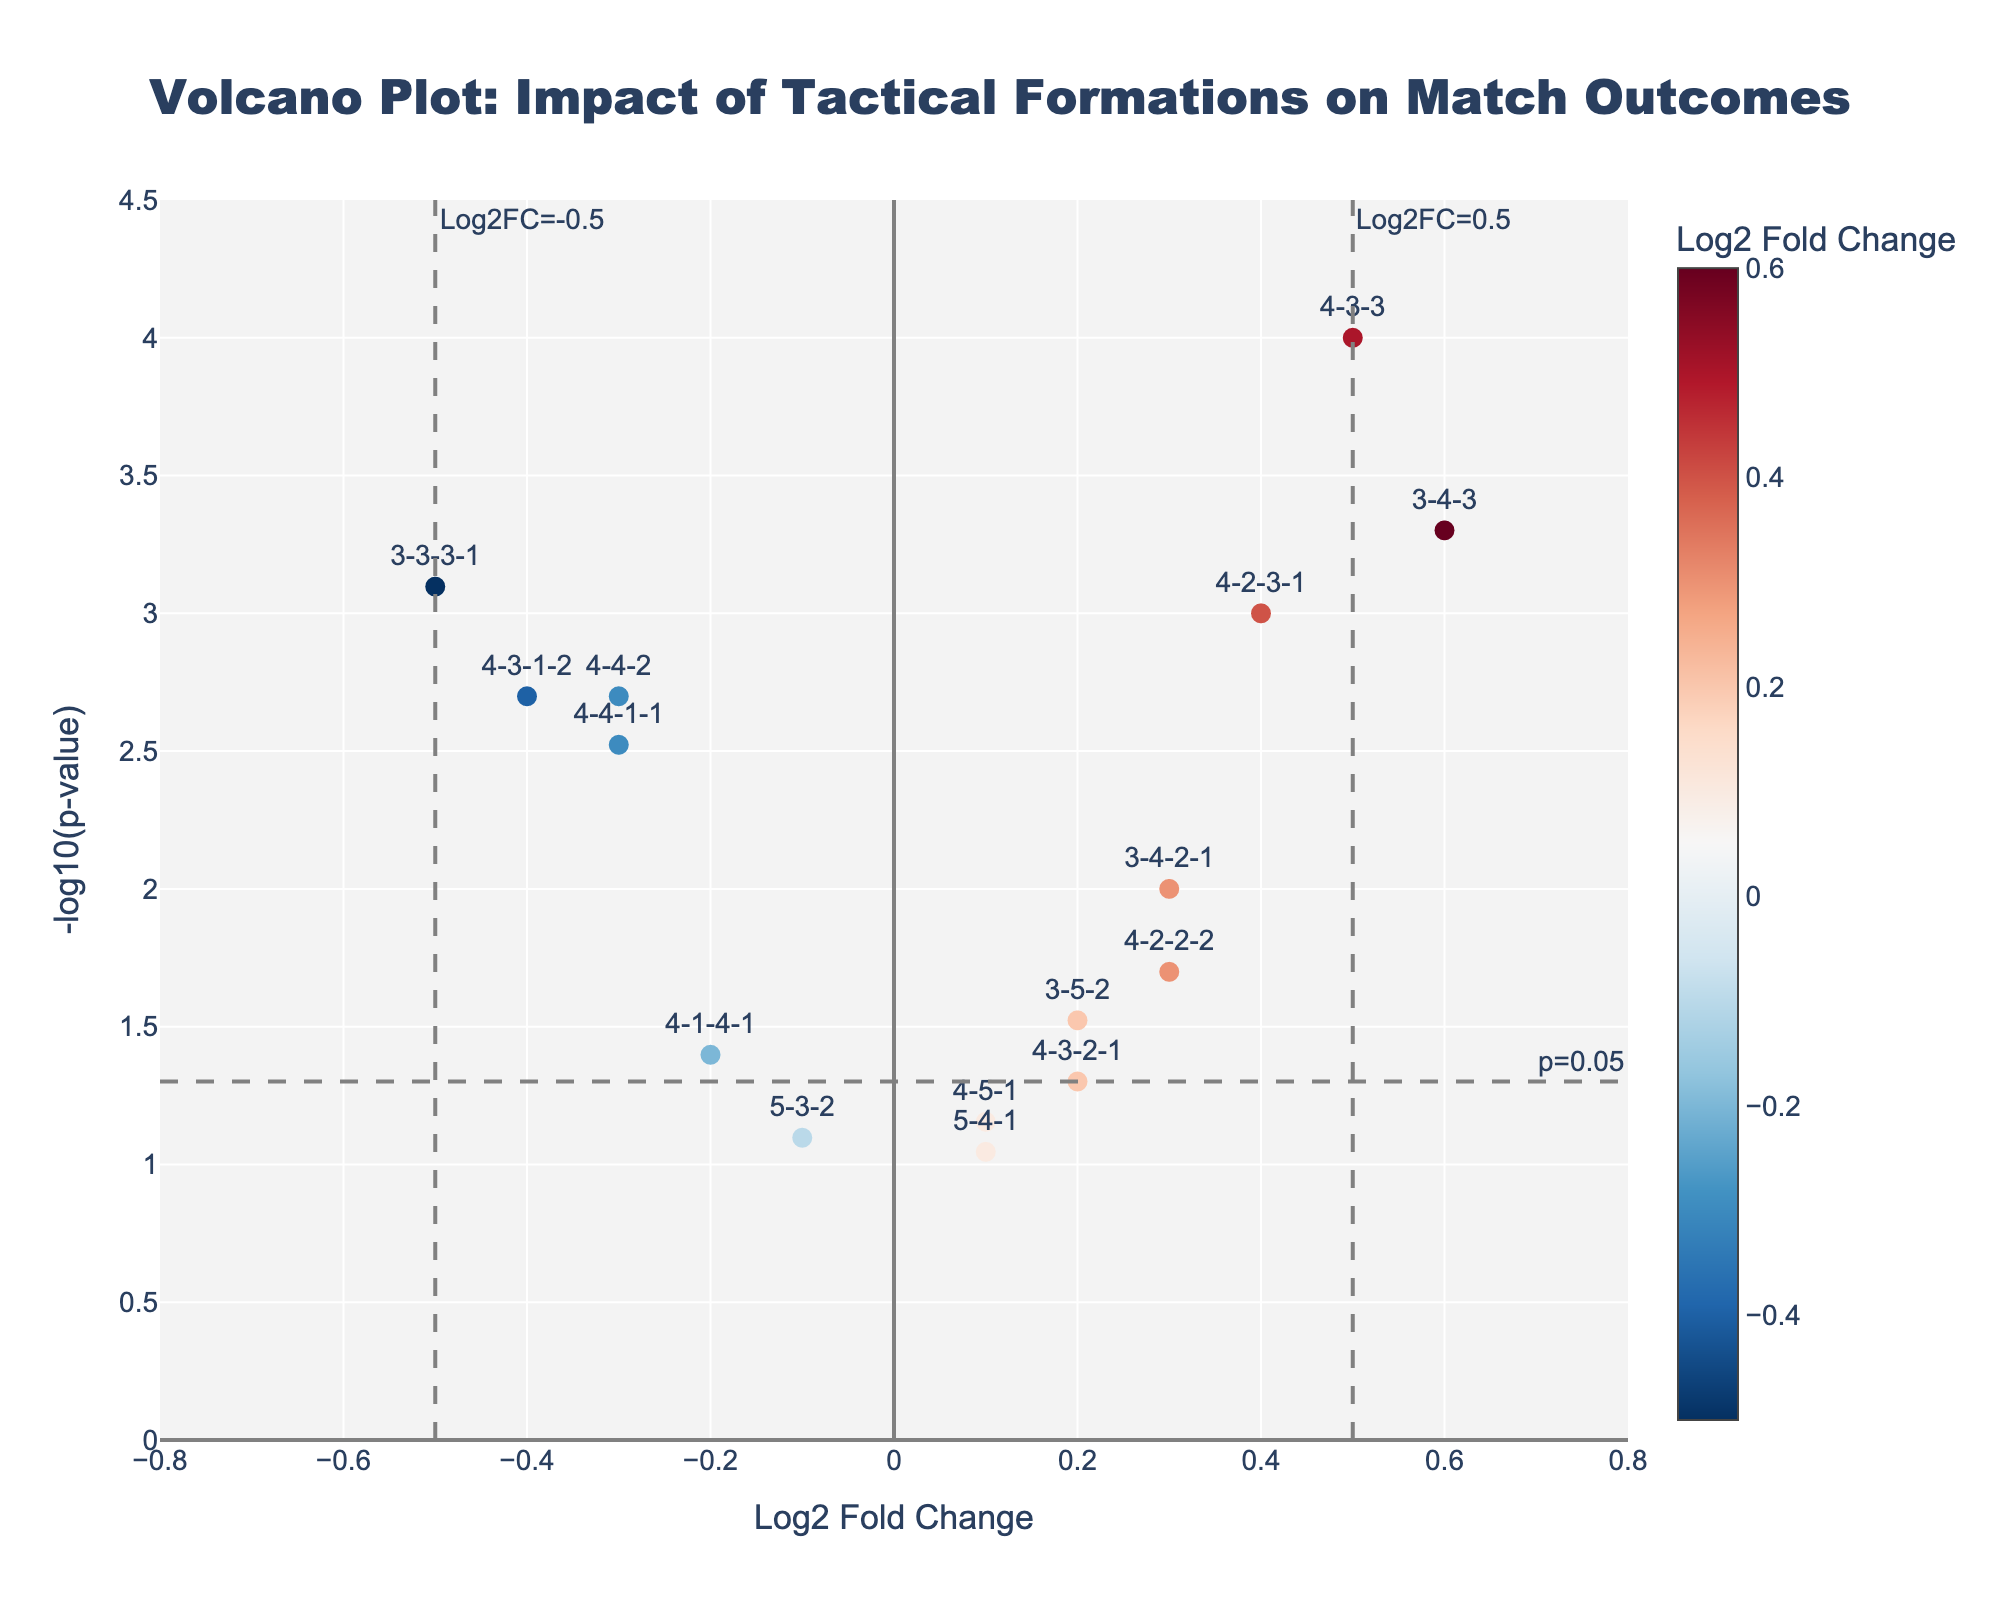What is the title of the plot? The title can be easily located at the top center of the figure. It reads "Volcano Plot: Impact of Tactical Formations on Match Outcomes".
Answer: Volcano Plot: Impact of Tactical Formations on Match Outcomes What are the x-axis and y-axis labels? The x-axis label is "Log2 Fold Change", and the y-axis label is "-log10(p-value)". These labels describe what each axis represents.
Answer: Log2 Fold Change, -log10(p-value) Which formation has the smallest p-value? To find the smallest p-value, look for the data point with the highest -log10(p-value) value. The highest point on the y-axis represents the smallest p-value.
Answer: 4-3-3 How many formations have a Log2FoldChange greater than 0.5? Scan the x-axis to find formations with Log2FoldChange values greater than 0.5. Count the number of data points in this region.
Answer: 2 Which formations are considered statistically significant with a p-value less than 0.05? Identify dots above the y-line at -log10(p-value)=1.3 (since -log10(0.05) ≈ 1.3). Formations represented by these points are statistically significant.
Answer: 4-4-2, 4-3-3, 3-5-2, 4-2-3-1, 3-4-3, 4-3-1-2, 3-3-3-1, 4-4-1-1, 4-2-2-2 Which formation has the highest positive Log2FoldChange and is statistically significant? Among the statistically significant points (above the -log10(p-value)=1.3 line), find the one with the highest Log2 Fold Change on the right side of the plot.
Answer: 3-4-3 Compare the formations 4-4-2 and 3-3-3-1. Which one has a lower p-value? Look at the y-axis values for 4-4-2 and 3-3-3-1. The formation with the higher -log10(p-value) has a lower actual p-value.
Answer: 3-3-3-1 Which formation has the most negative Log2FoldChange but is not statistically significant? First, identify non-significant points (below the -log10(p-value)=1.3 line), then find the one with the lowest Log2FoldChange value.
Answer: 5-3-2 On average, are the statistically significant formations more likely to have positive or negative Log2FoldChange values? Count how many significant formations have positive Log2FoldChange values and how many have negative ones, then compare the counts. 6 out of 9 significant formations have positive values, indicating a trend towards positive Log2FoldChange.
Answer: Positive 